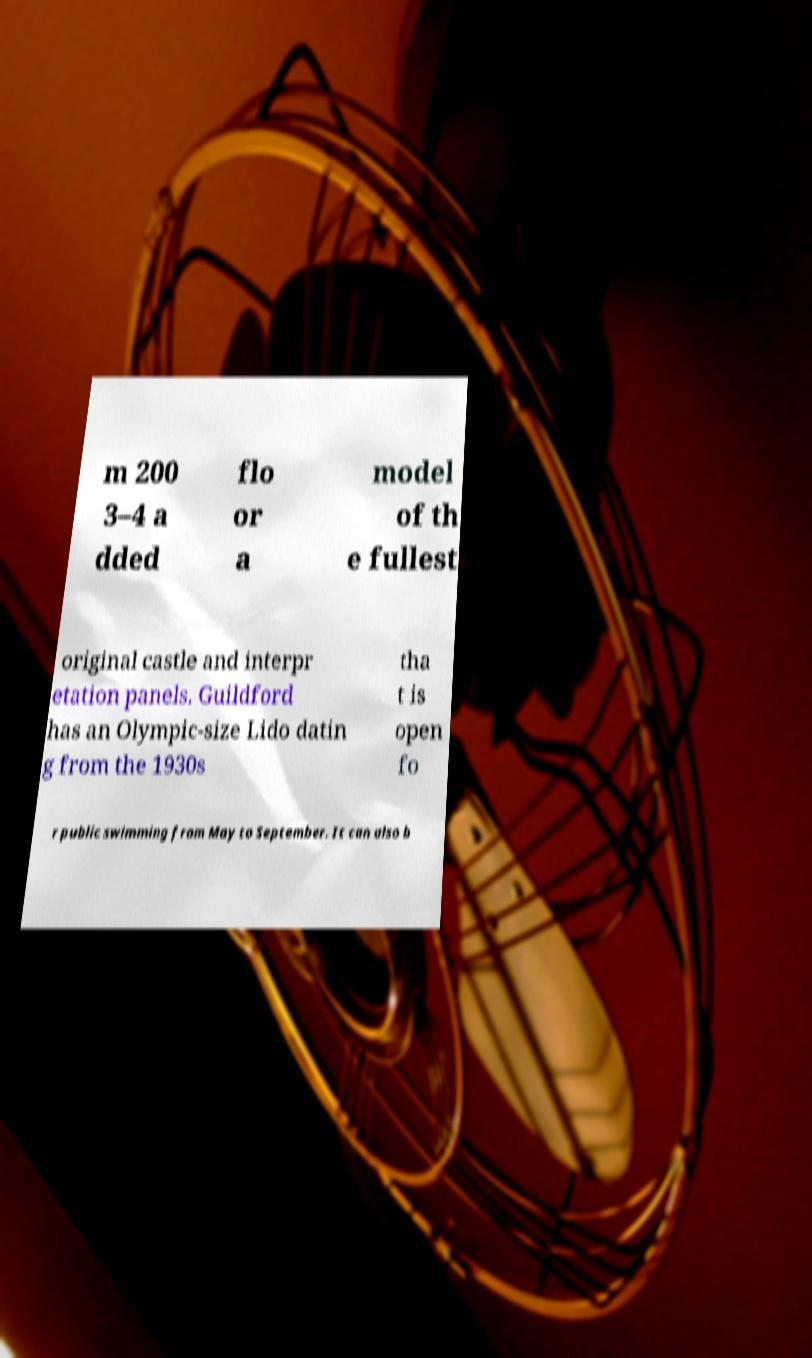I need the written content from this picture converted into text. Can you do that? m 200 3–4 a dded flo or a model of th e fullest original castle and interpr etation panels. Guildford has an Olympic-size Lido datin g from the 1930s tha t is open fo r public swimming from May to September. It can also b 